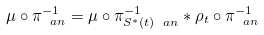Convert formula to latex. <formula><loc_0><loc_0><loc_500><loc_500>\mu \circ \pi _ { \ a n } ^ { - 1 } = \mu \circ \pi ^ { - 1 } _ { S ^ { \ast } ( t ) \ a n } \ast \rho _ { t } \circ \pi _ { \ a n } ^ { - 1 }</formula> 